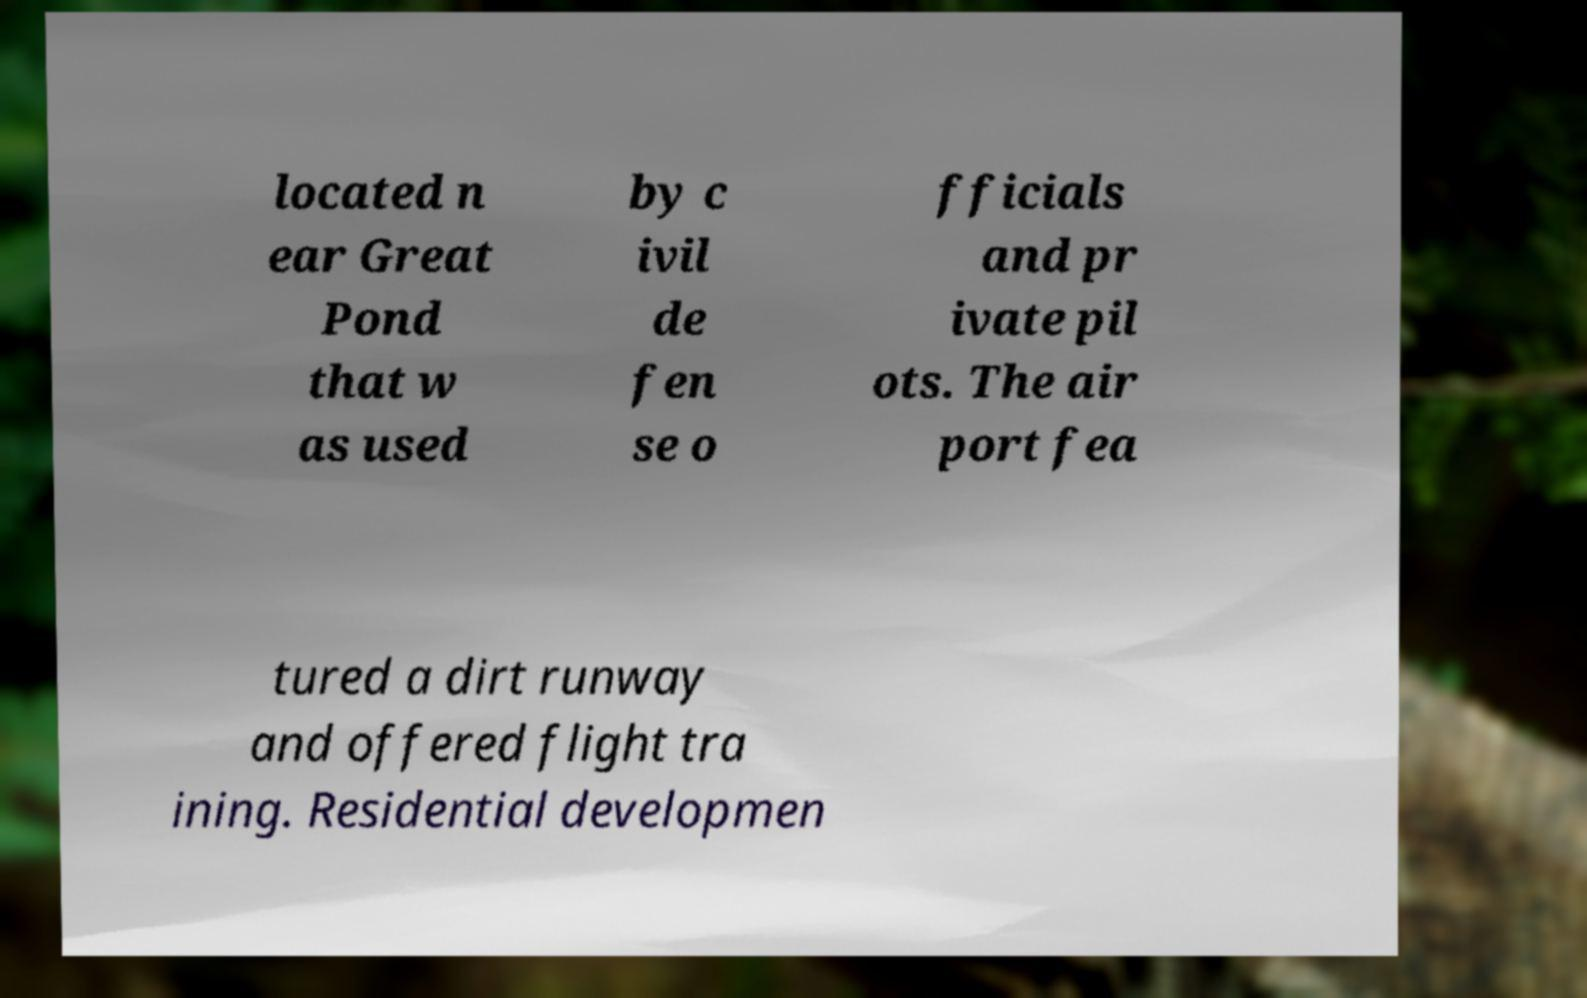Please identify and transcribe the text found in this image. located n ear Great Pond that w as used by c ivil de fen se o fficials and pr ivate pil ots. The air port fea tured a dirt runway and offered flight tra ining. Residential developmen 